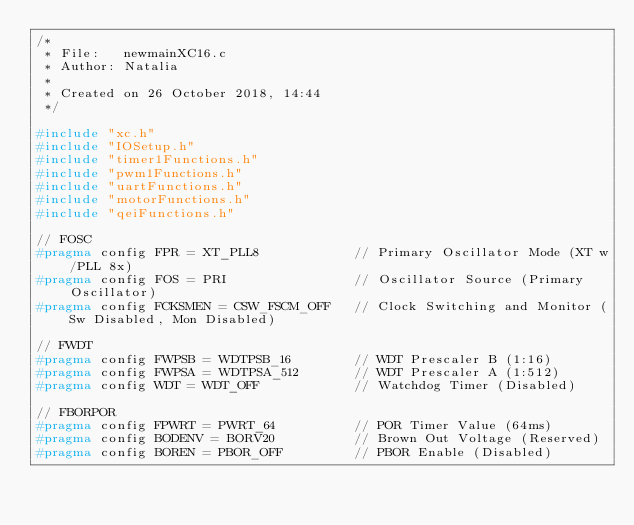Convert code to text. <code><loc_0><loc_0><loc_500><loc_500><_C_>/*
 * File:   newmainXC16.c
 * Author: Natalia
 *
 * Created on 26 October 2018, 14:44
 */

#include "xc.h"
#include "IOSetup.h"
#include "timer1Functions.h"
#include "pwm1Functions.h"
#include "uartFunctions.h"
#include "motorFunctions.h"
#include "qeiFunctions.h"

// FOSC
#pragma config FPR = XT_PLL8            // Primary Oscillator Mode (XT w/PLL 8x)
#pragma config FOS = PRI                // Oscillator Source (Primary Oscillator)
#pragma config FCKSMEN = CSW_FSCM_OFF   // Clock Switching and Monitor (Sw Disabled, Mon Disabled)

// FWDT
#pragma config FWPSB = WDTPSB_16        // WDT Prescaler B (1:16)
#pragma config FWPSA = WDTPSA_512       // WDT Prescaler A (1:512)
#pragma config WDT = WDT_OFF            // Watchdog Timer (Disabled)

// FBORPOR
#pragma config FPWRT = PWRT_64          // POR Timer Value (64ms)
#pragma config BODENV = BORV20          // Brown Out Voltage (Reserved)
#pragma config BOREN = PBOR_OFF         // PBOR Enable (Disabled)</code> 